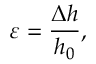Convert formula to latex. <formula><loc_0><loc_0><loc_500><loc_500>\varepsilon = \frac { \Delta h } { h _ { 0 } } ,</formula> 